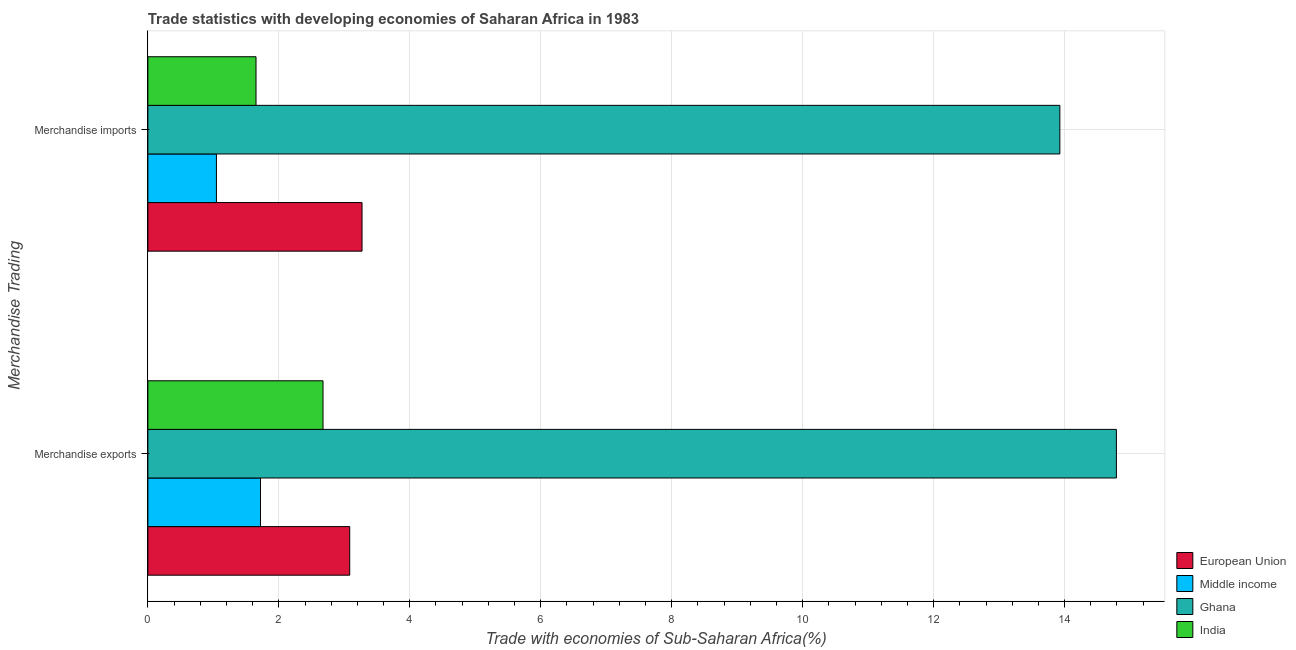How many different coloured bars are there?
Make the answer very short. 4. How many bars are there on the 1st tick from the top?
Offer a very short reply. 4. What is the label of the 1st group of bars from the top?
Your answer should be compact. Merchandise imports. What is the merchandise imports in India?
Ensure brevity in your answer.  1.65. Across all countries, what is the maximum merchandise exports?
Provide a succinct answer. 14.79. Across all countries, what is the minimum merchandise exports?
Ensure brevity in your answer.  1.72. What is the total merchandise exports in the graph?
Provide a succinct answer. 22.27. What is the difference between the merchandise exports in Middle income and that in European Union?
Your answer should be very brief. -1.36. What is the difference between the merchandise exports in India and the merchandise imports in European Union?
Provide a short and direct response. -0.6. What is the average merchandise exports per country?
Offer a terse response. 5.57. What is the difference between the merchandise imports and merchandise exports in Ghana?
Keep it short and to the point. -0.86. What is the ratio of the merchandise exports in European Union to that in Ghana?
Provide a succinct answer. 0.21. How many bars are there?
Your response must be concise. 8. How many countries are there in the graph?
Your answer should be very brief. 4. What is the difference between two consecutive major ticks on the X-axis?
Provide a succinct answer. 2. Does the graph contain any zero values?
Your response must be concise. No. Does the graph contain grids?
Offer a very short reply. Yes. Where does the legend appear in the graph?
Provide a short and direct response. Bottom right. How many legend labels are there?
Offer a terse response. 4. How are the legend labels stacked?
Your response must be concise. Vertical. What is the title of the graph?
Make the answer very short. Trade statistics with developing economies of Saharan Africa in 1983. What is the label or title of the X-axis?
Make the answer very short. Trade with economies of Sub-Saharan Africa(%). What is the label or title of the Y-axis?
Make the answer very short. Merchandise Trading. What is the Trade with economies of Sub-Saharan Africa(%) in European Union in Merchandise exports?
Make the answer very short. 3.08. What is the Trade with economies of Sub-Saharan Africa(%) in Middle income in Merchandise exports?
Your response must be concise. 1.72. What is the Trade with economies of Sub-Saharan Africa(%) of Ghana in Merchandise exports?
Your response must be concise. 14.79. What is the Trade with economies of Sub-Saharan Africa(%) in India in Merchandise exports?
Your answer should be compact. 2.67. What is the Trade with economies of Sub-Saharan Africa(%) of European Union in Merchandise imports?
Provide a short and direct response. 3.27. What is the Trade with economies of Sub-Saharan Africa(%) of Middle income in Merchandise imports?
Your answer should be very brief. 1.05. What is the Trade with economies of Sub-Saharan Africa(%) in Ghana in Merchandise imports?
Your response must be concise. 13.93. What is the Trade with economies of Sub-Saharan Africa(%) in India in Merchandise imports?
Provide a succinct answer. 1.65. Across all Merchandise Trading, what is the maximum Trade with economies of Sub-Saharan Africa(%) in European Union?
Your answer should be compact. 3.27. Across all Merchandise Trading, what is the maximum Trade with economies of Sub-Saharan Africa(%) of Middle income?
Offer a terse response. 1.72. Across all Merchandise Trading, what is the maximum Trade with economies of Sub-Saharan Africa(%) of Ghana?
Ensure brevity in your answer.  14.79. Across all Merchandise Trading, what is the maximum Trade with economies of Sub-Saharan Africa(%) of India?
Your answer should be very brief. 2.67. Across all Merchandise Trading, what is the minimum Trade with economies of Sub-Saharan Africa(%) in European Union?
Your response must be concise. 3.08. Across all Merchandise Trading, what is the minimum Trade with economies of Sub-Saharan Africa(%) in Middle income?
Ensure brevity in your answer.  1.05. Across all Merchandise Trading, what is the minimum Trade with economies of Sub-Saharan Africa(%) in Ghana?
Give a very brief answer. 13.93. Across all Merchandise Trading, what is the minimum Trade with economies of Sub-Saharan Africa(%) of India?
Keep it short and to the point. 1.65. What is the total Trade with economies of Sub-Saharan Africa(%) in European Union in the graph?
Keep it short and to the point. 6.35. What is the total Trade with economies of Sub-Saharan Africa(%) in Middle income in the graph?
Ensure brevity in your answer.  2.77. What is the total Trade with economies of Sub-Saharan Africa(%) in Ghana in the graph?
Your answer should be very brief. 28.72. What is the total Trade with economies of Sub-Saharan Africa(%) of India in the graph?
Provide a short and direct response. 4.33. What is the difference between the Trade with economies of Sub-Saharan Africa(%) in European Union in Merchandise exports and that in Merchandise imports?
Make the answer very short. -0.19. What is the difference between the Trade with economies of Sub-Saharan Africa(%) in Middle income in Merchandise exports and that in Merchandise imports?
Offer a terse response. 0.67. What is the difference between the Trade with economies of Sub-Saharan Africa(%) in Ghana in Merchandise exports and that in Merchandise imports?
Provide a succinct answer. 0.86. What is the difference between the Trade with economies of Sub-Saharan Africa(%) in India in Merchandise exports and that in Merchandise imports?
Offer a very short reply. 1.02. What is the difference between the Trade with economies of Sub-Saharan Africa(%) of European Union in Merchandise exports and the Trade with economies of Sub-Saharan Africa(%) of Middle income in Merchandise imports?
Offer a very short reply. 2.04. What is the difference between the Trade with economies of Sub-Saharan Africa(%) in European Union in Merchandise exports and the Trade with economies of Sub-Saharan Africa(%) in Ghana in Merchandise imports?
Make the answer very short. -10.84. What is the difference between the Trade with economies of Sub-Saharan Africa(%) in European Union in Merchandise exports and the Trade with economies of Sub-Saharan Africa(%) in India in Merchandise imports?
Your response must be concise. 1.43. What is the difference between the Trade with economies of Sub-Saharan Africa(%) of Middle income in Merchandise exports and the Trade with economies of Sub-Saharan Africa(%) of Ghana in Merchandise imports?
Provide a short and direct response. -12.21. What is the difference between the Trade with economies of Sub-Saharan Africa(%) of Middle income in Merchandise exports and the Trade with economies of Sub-Saharan Africa(%) of India in Merchandise imports?
Keep it short and to the point. 0.07. What is the difference between the Trade with economies of Sub-Saharan Africa(%) of Ghana in Merchandise exports and the Trade with economies of Sub-Saharan Africa(%) of India in Merchandise imports?
Your answer should be compact. 13.14. What is the average Trade with economies of Sub-Saharan Africa(%) in European Union per Merchandise Trading?
Your answer should be very brief. 3.18. What is the average Trade with economies of Sub-Saharan Africa(%) of Middle income per Merchandise Trading?
Offer a terse response. 1.38. What is the average Trade with economies of Sub-Saharan Africa(%) in Ghana per Merchandise Trading?
Give a very brief answer. 14.36. What is the average Trade with economies of Sub-Saharan Africa(%) of India per Merchandise Trading?
Your answer should be very brief. 2.16. What is the difference between the Trade with economies of Sub-Saharan Africa(%) in European Union and Trade with economies of Sub-Saharan Africa(%) in Middle income in Merchandise exports?
Keep it short and to the point. 1.36. What is the difference between the Trade with economies of Sub-Saharan Africa(%) of European Union and Trade with economies of Sub-Saharan Africa(%) of Ghana in Merchandise exports?
Keep it short and to the point. -11.71. What is the difference between the Trade with economies of Sub-Saharan Africa(%) in European Union and Trade with economies of Sub-Saharan Africa(%) in India in Merchandise exports?
Your answer should be compact. 0.41. What is the difference between the Trade with economies of Sub-Saharan Africa(%) of Middle income and Trade with economies of Sub-Saharan Africa(%) of Ghana in Merchandise exports?
Provide a short and direct response. -13.07. What is the difference between the Trade with economies of Sub-Saharan Africa(%) of Middle income and Trade with economies of Sub-Saharan Africa(%) of India in Merchandise exports?
Your answer should be very brief. -0.95. What is the difference between the Trade with economies of Sub-Saharan Africa(%) in Ghana and Trade with economies of Sub-Saharan Africa(%) in India in Merchandise exports?
Your answer should be compact. 12.12. What is the difference between the Trade with economies of Sub-Saharan Africa(%) in European Union and Trade with economies of Sub-Saharan Africa(%) in Middle income in Merchandise imports?
Offer a terse response. 2.22. What is the difference between the Trade with economies of Sub-Saharan Africa(%) in European Union and Trade with economies of Sub-Saharan Africa(%) in Ghana in Merchandise imports?
Make the answer very short. -10.66. What is the difference between the Trade with economies of Sub-Saharan Africa(%) in European Union and Trade with economies of Sub-Saharan Africa(%) in India in Merchandise imports?
Provide a succinct answer. 1.62. What is the difference between the Trade with economies of Sub-Saharan Africa(%) in Middle income and Trade with economies of Sub-Saharan Africa(%) in Ghana in Merchandise imports?
Provide a short and direct response. -12.88. What is the difference between the Trade with economies of Sub-Saharan Africa(%) in Middle income and Trade with economies of Sub-Saharan Africa(%) in India in Merchandise imports?
Your answer should be very brief. -0.6. What is the difference between the Trade with economies of Sub-Saharan Africa(%) in Ghana and Trade with economies of Sub-Saharan Africa(%) in India in Merchandise imports?
Offer a terse response. 12.28. What is the ratio of the Trade with economies of Sub-Saharan Africa(%) in European Union in Merchandise exports to that in Merchandise imports?
Make the answer very short. 0.94. What is the ratio of the Trade with economies of Sub-Saharan Africa(%) in Middle income in Merchandise exports to that in Merchandise imports?
Your response must be concise. 1.64. What is the ratio of the Trade with economies of Sub-Saharan Africa(%) of Ghana in Merchandise exports to that in Merchandise imports?
Offer a terse response. 1.06. What is the ratio of the Trade with economies of Sub-Saharan Africa(%) in India in Merchandise exports to that in Merchandise imports?
Your answer should be compact. 1.62. What is the difference between the highest and the second highest Trade with economies of Sub-Saharan Africa(%) of European Union?
Ensure brevity in your answer.  0.19. What is the difference between the highest and the second highest Trade with economies of Sub-Saharan Africa(%) in Middle income?
Provide a succinct answer. 0.67. What is the difference between the highest and the second highest Trade with economies of Sub-Saharan Africa(%) in Ghana?
Your response must be concise. 0.86. What is the difference between the highest and the second highest Trade with economies of Sub-Saharan Africa(%) in India?
Offer a very short reply. 1.02. What is the difference between the highest and the lowest Trade with economies of Sub-Saharan Africa(%) of European Union?
Provide a short and direct response. 0.19. What is the difference between the highest and the lowest Trade with economies of Sub-Saharan Africa(%) of Middle income?
Keep it short and to the point. 0.67. What is the difference between the highest and the lowest Trade with economies of Sub-Saharan Africa(%) in Ghana?
Keep it short and to the point. 0.86. What is the difference between the highest and the lowest Trade with economies of Sub-Saharan Africa(%) of India?
Offer a very short reply. 1.02. 